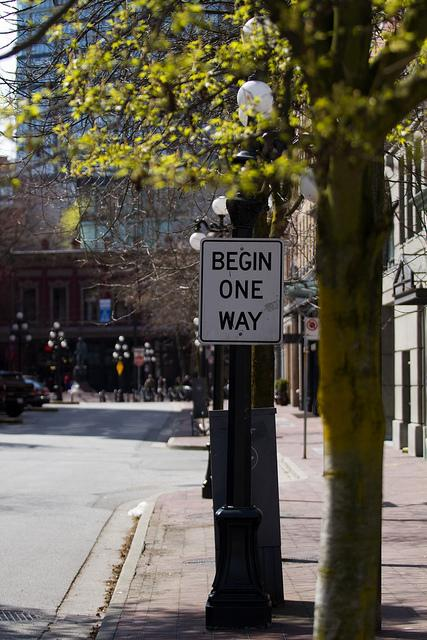What type of road is behind the person who took this picture? Please explain your reasoning. two way. The one way starts at the sign, so it must be two lanes elsewhere. 